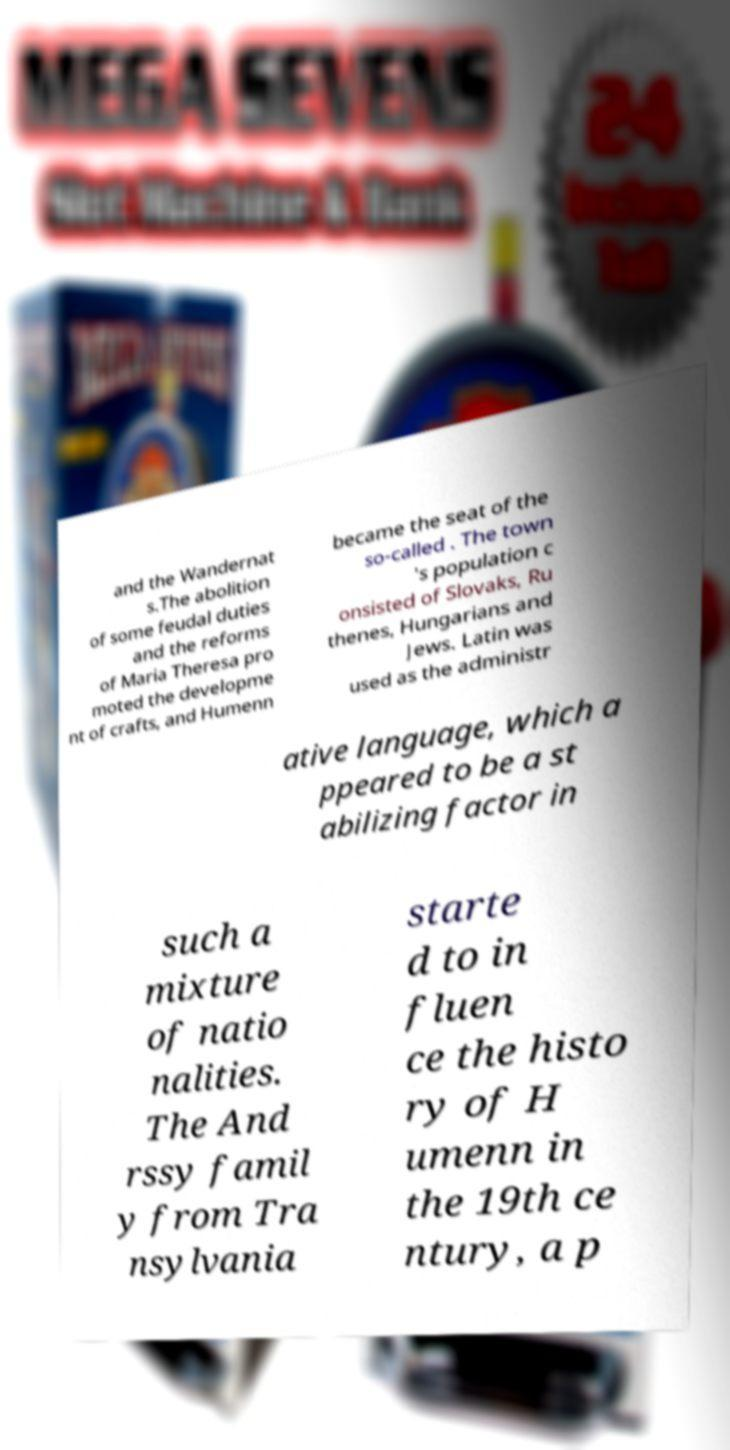What messages or text are displayed in this image? I need them in a readable, typed format. and the Wandernat s.The abolition of some feudal duties and the reforms of Maria Theresa pro moted the developme nt of crafts, and Humenn became the seat of the so-called . The town 's population c onsisted of Slovaks, Ru thenes, Hungarians and Jews. Latin was used as the administr ative language, which a ppeared to be a st abilizing factor in such a mixture of natio nalities. The And rssy famil y from Tra nsylvania starte d to in fluen ce the histo ry of H umenn in the 19th ce ntury, a p 